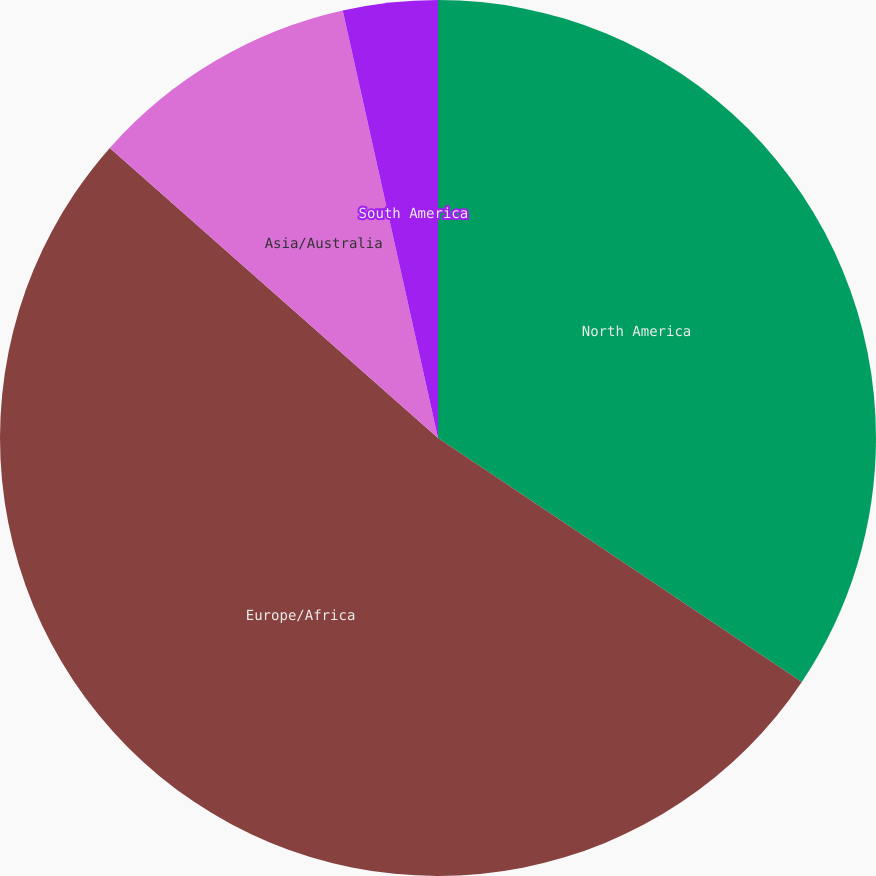Convert chart. <chart><loc_0><loc_0><loc_500><loc_500><pie_chart><fcel>North America<fcel>Europe/Africa<fcel>Asia/Australia<fcel>South America<nl><fcel>34.4%<fcel>52.12%<fcel>9.99%<fcel>3.49%<nl></chart> 